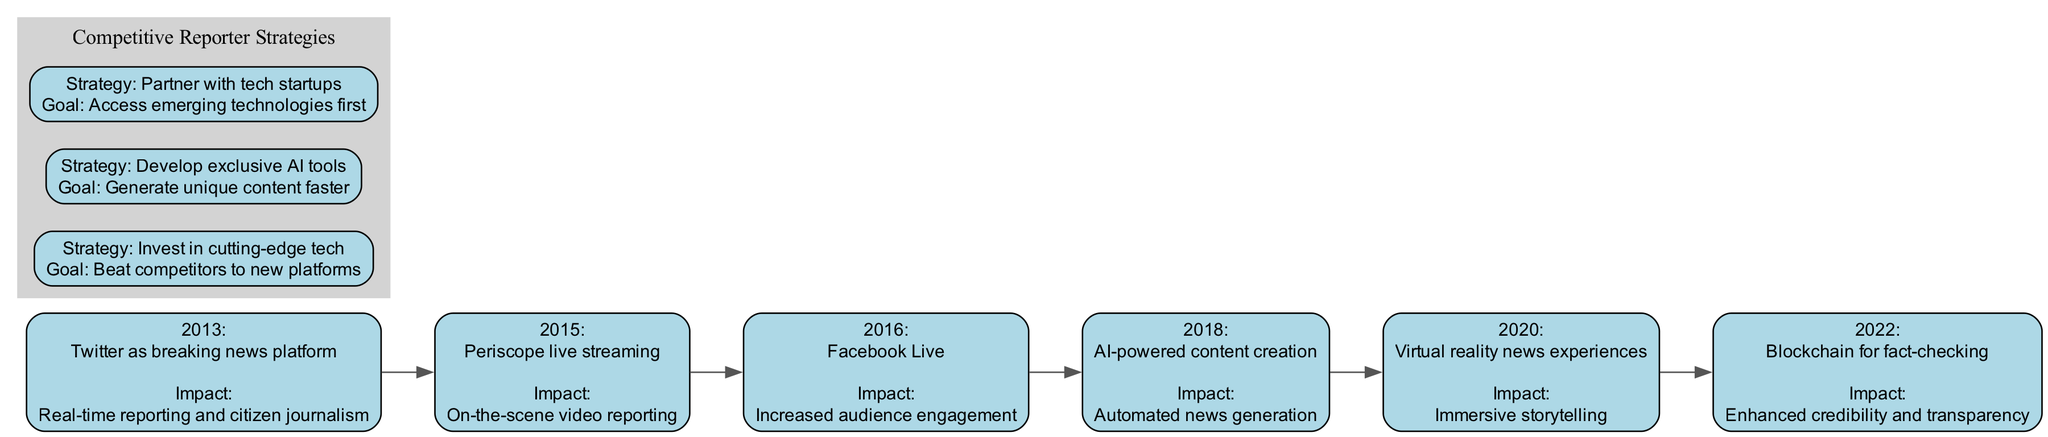What technological advancement occurred in 2015? The diagram specifically lists the advancements chronologically by year, with "Periscope live streaming" being highlighted for the year 2015.
Answer: Periscope live streaming What impact did AI-powered content creation have? The diagram notes that AI-powered content creation was introduced in 2018 and describes its impact as "Automated news generation."
Answer: Automated news generation How many years are represented in the timeline? By counting the number of distinct years listed in the timeline (2013, 2015, 2016, 2018, 2020, 2022), we find that there are 6 years represented.
Answer: 6 Which advancement introduced immersive storytelling? The diagram marks "Virtual reality news experiences" as the advancement related to immersive storytelling, which specifically took place in 2020.
Answer: Virtual reality news experiences In what year was blockchain for fact-checking introduced? Referring to the timeline, it's evident that the introduction of blockchain for fact-checking is associated with the year 2022.
Answer: 2022 What is one strategy a competitive reporter should follow to get new platforms faster? According to the persona elements included in the diagram, investing in cutting-edge tech emerges as a strategy to gain an advantage over competitors in accessing new platforms.
Answer: Invest in cutting-edge tech What relationship exists between Twitter and citizen journalism? The diagram connects Twitter as a breaking news platform with the impact of enabling real-time reporting and citizen journalism, showcasing how they relate.
Answer: Real-time reporting and citizen journalism How many competitive reporter strategies are listed in the diagram? The diagram displays three distinct competitive reporter strategies under persona elements, therefore the total number of strategies is three.
Answer: 3 What was the main impact of Facebook Live according to the diagram? The timeline identifies Facebook Live, which was introduced in 2016, and states that its main impact was increased audience engagement.
Answer: Increased audience engagement 